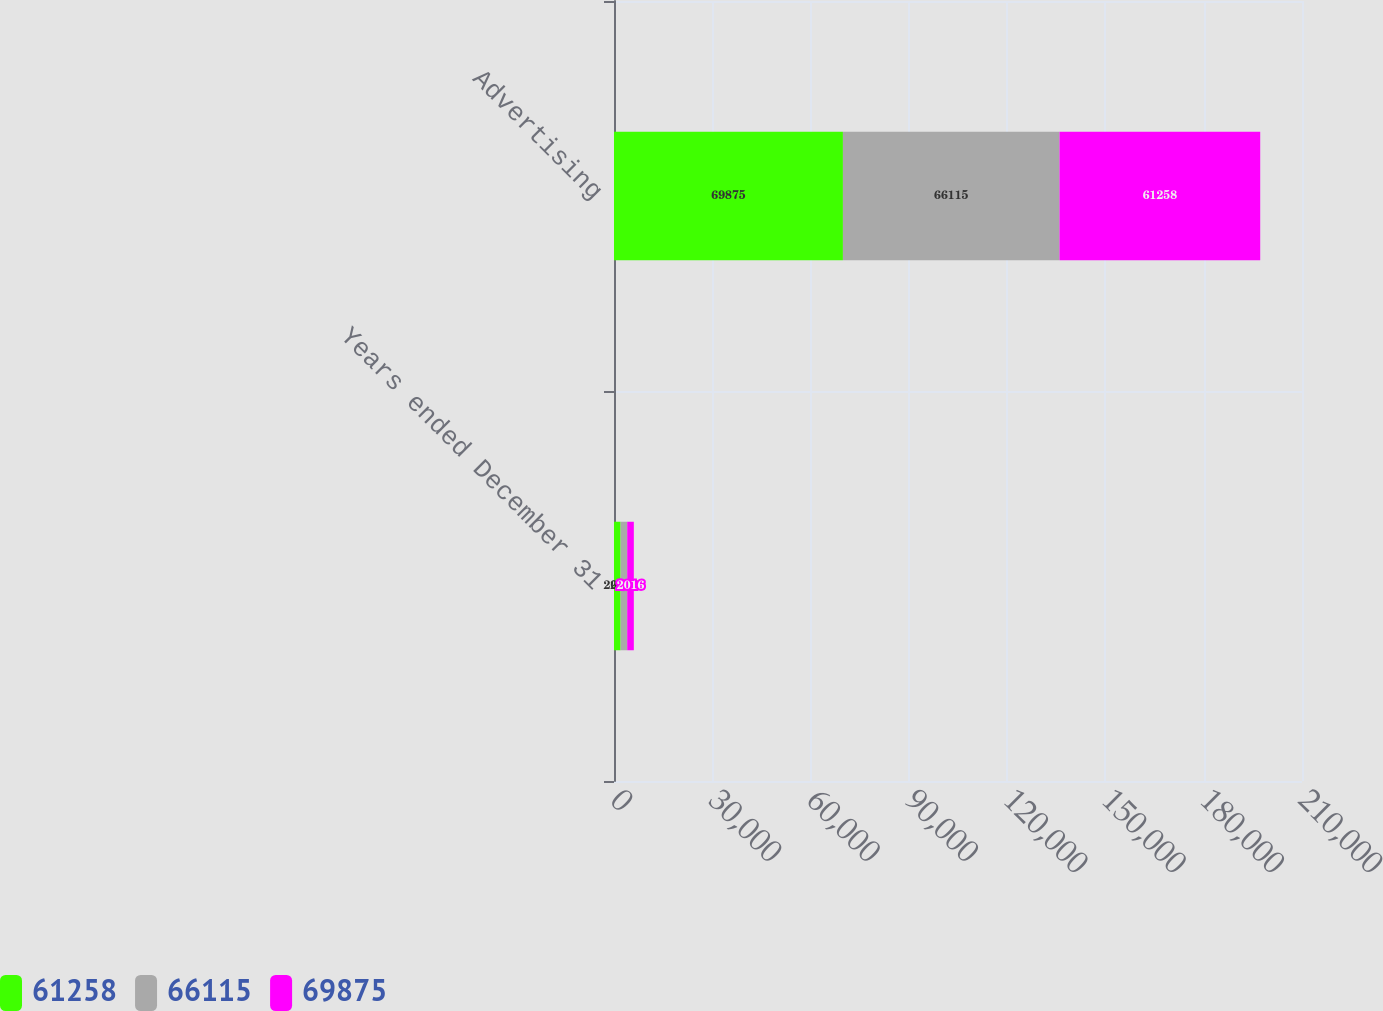Convert chart to OTSL. <chart><loc_0><loc_0><loc_500><loc_500><stacked_bar_chart><ecel><fcel>Years ended December 31<fcel>Advertising<nl><fcel>61258<fcel>2018<fcel>69875<nl><fcel>66115<fcel>2017<fcel>66115<nl><fcel>69875<fcel>2016<fcel>61258<nl></chart> 